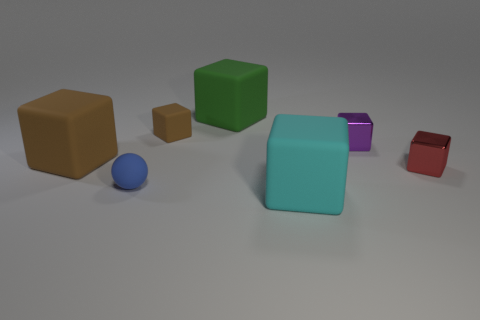Subtract all brown matte cubes. How many cubes are left? 4 Subtract 3 cubes. How many cubes are left? 3 Subtract all brown blocks. How many blocks are left? 4 Add 3 small purple shiny blocks. How many objects exist? 10 Subtract all cyan cubes. Subtract all brown cylinders. How many cubes are left? 5 Subtract all blocks. How many objects are left? 1 Add 5 red matte objects. How many red matte objects exist? 5 Subtract 0 purple cylinders. How many objects are left? 7 Subtract all purple metallic blocks. Subtract all red metallic blocks. How many objects are left? 5 Add 1 small metallic objects. How many small metallic objects are left? 3 